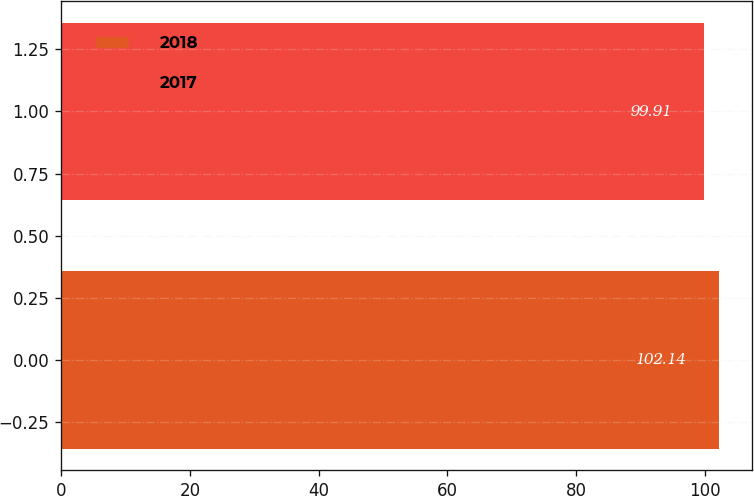Convert chart. <chart><loc_0><loc_0><loc_500><loc_500><bar_chart><fcel>2018<fcel>2017<nl><fcel>102.14<fcel>99.91<nl></chart> 